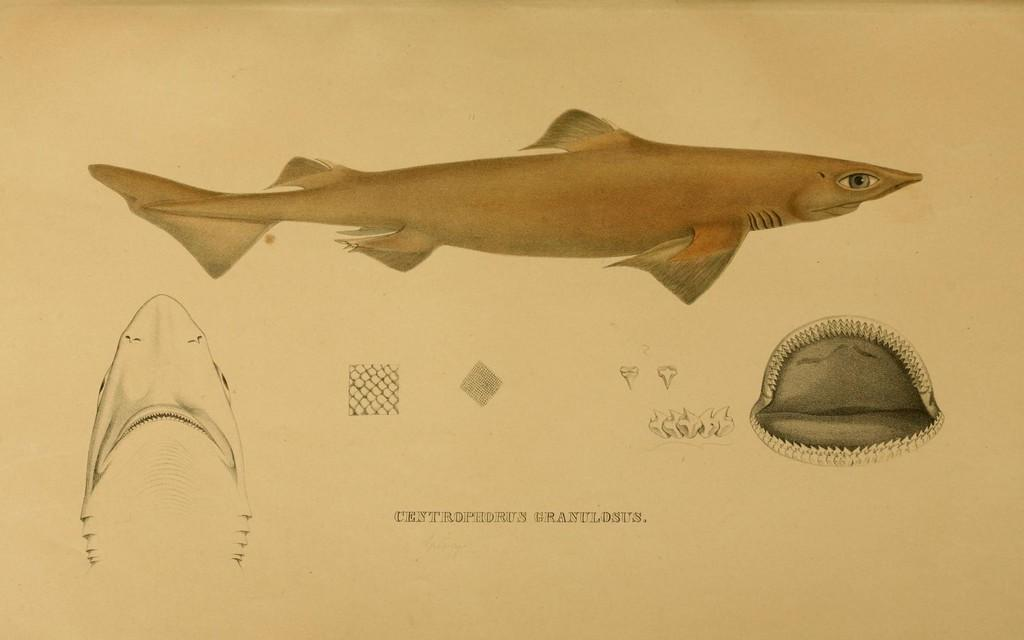What type of image is being described? The image is a drawing. What else can be found within the drawing? There is text and parts of fish in the drawing. Can you describe the fish in the drawing? There is a visible fish in the drawing. What type of pies are being served in the drawing? There are no pies present in the drawing; it features a drawing with text and fish. 